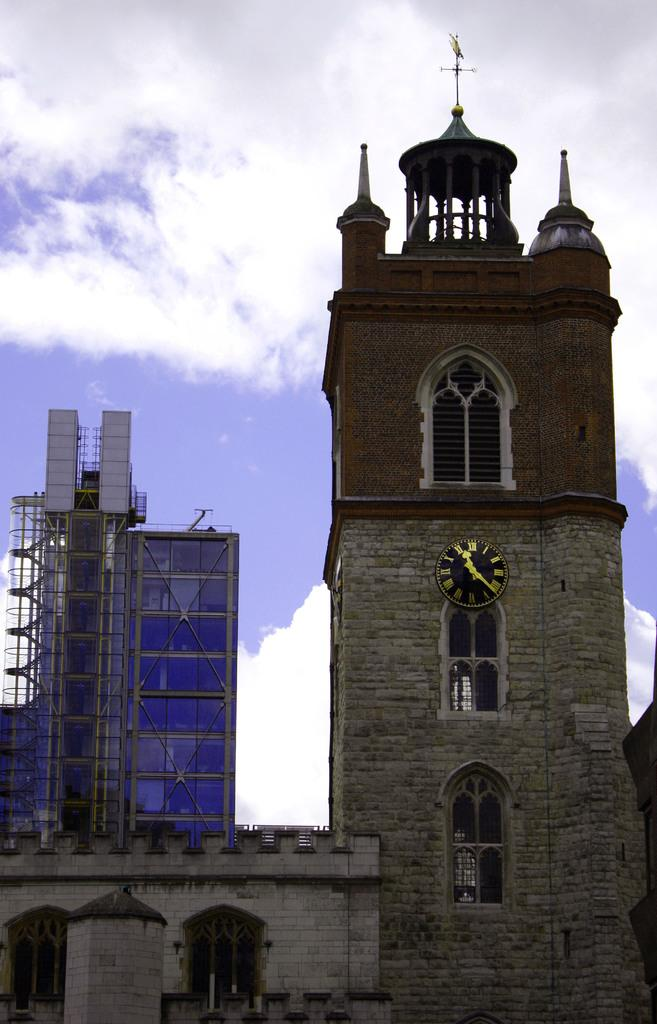What type of structures can be seen in the image? There are buildings in the image. Are there any specific features on the buildings? Yes, there is a clock on one of the buildings and an antenna on another building. What can be seen in the sky in the image? There are clouds visible at the top of the image. Can you tell me how many grapes are hanging from the antenna in the image? There are no grapes present in the image, and they are not hanging from the antenna. What type of chicken can be seen playing near the clock in the image? There are no chickens present in the image, and they are not playing near the clock. 